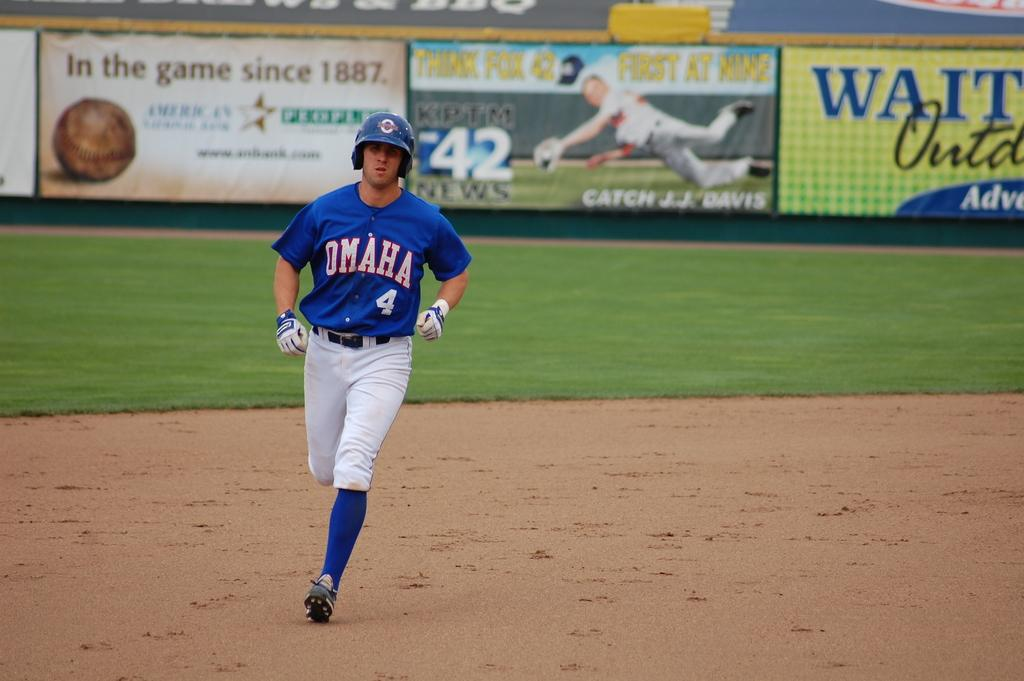<image>
Present a compact description of the photo's key features. Omaha baseball player #4 runs the bases in his blue uniform in front of several advertising signs, one that says Catch J.J. Davis on 42 News. 